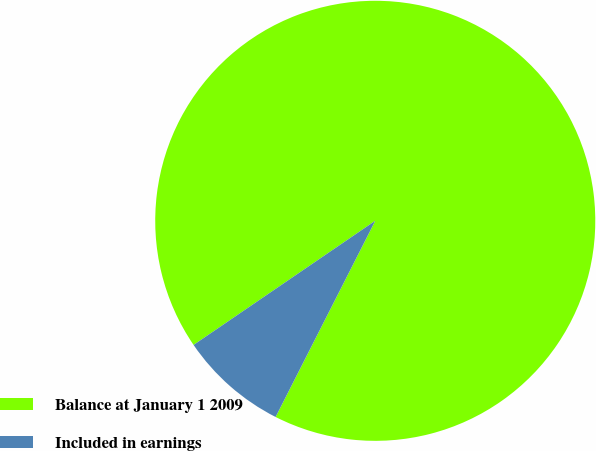<chart> <loc_0><loc_0><loc_500><loc_500><pie_chart><fcel>Balance at January 1 2009<fcel>Included in earnings<nl><fcel>92.02%<fcel>7.98%<nl></chart> 